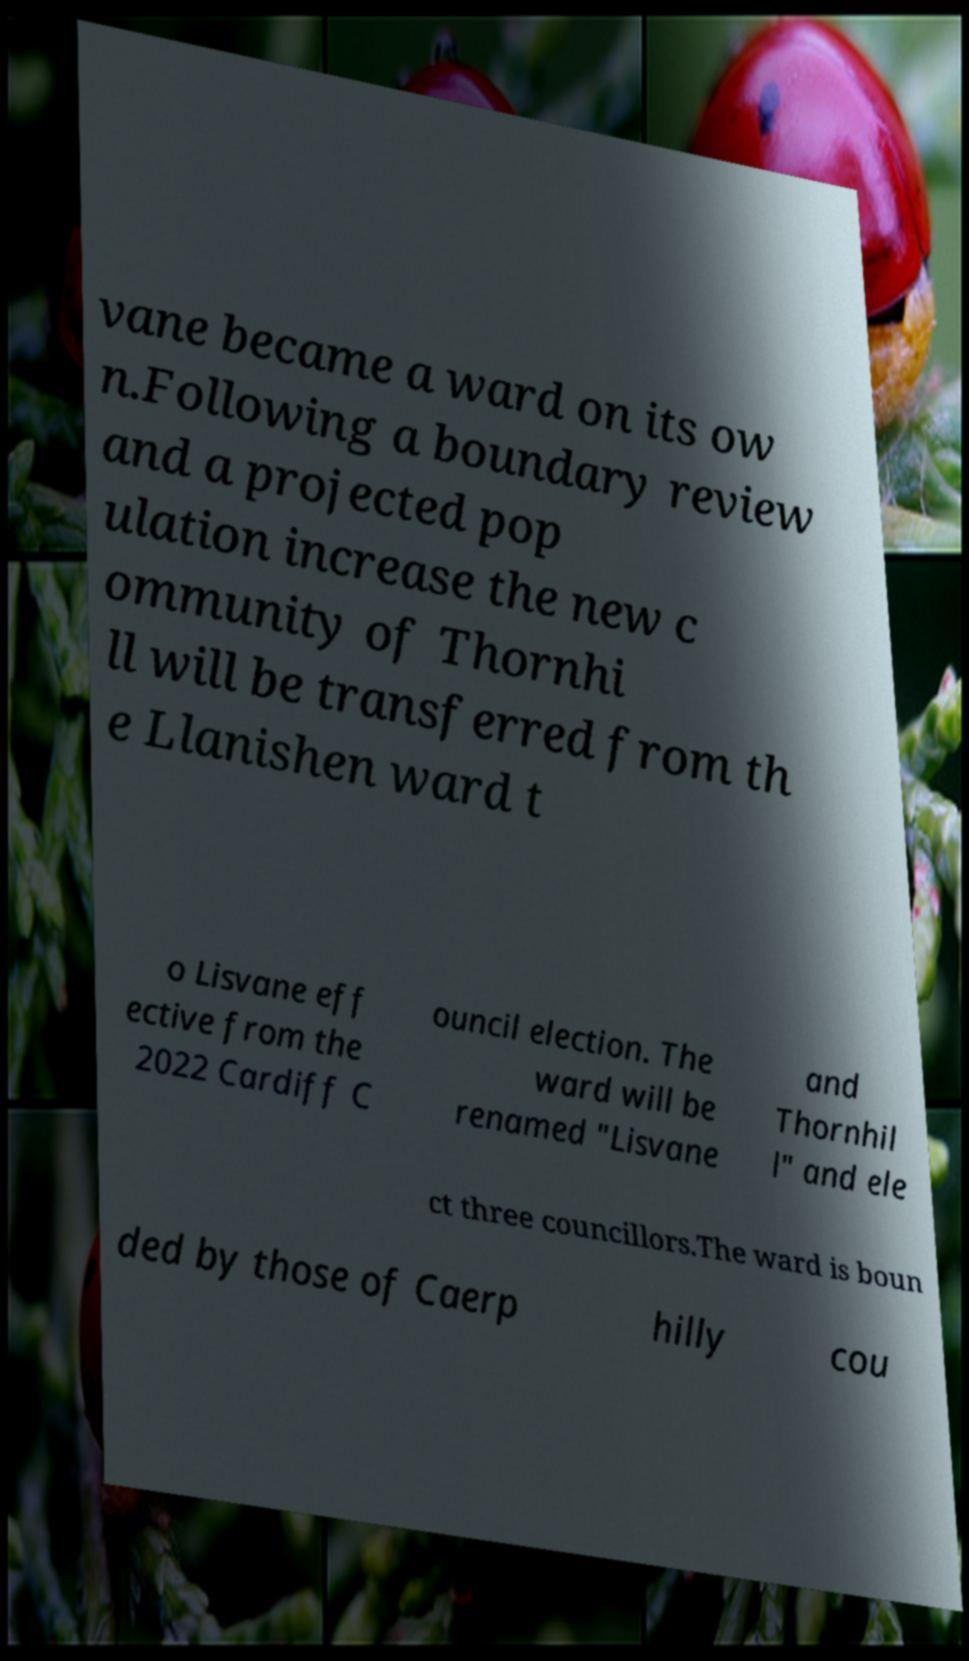I need the written content from this picture converted into text. Can you do that? vane became a ward on its ow n.Following a boundary review and a projected pop ulation increase the new c ommunity of Thornhi ll will be transferred from th e Llanishen ward t o Lisvane eff ective from the 2022 Cardiff C ouncil election. The ward will be renamed "Lisvane and Thornhil l" and ele ct three councillors.The ward is boun ded by those of Caerp hilly cou 